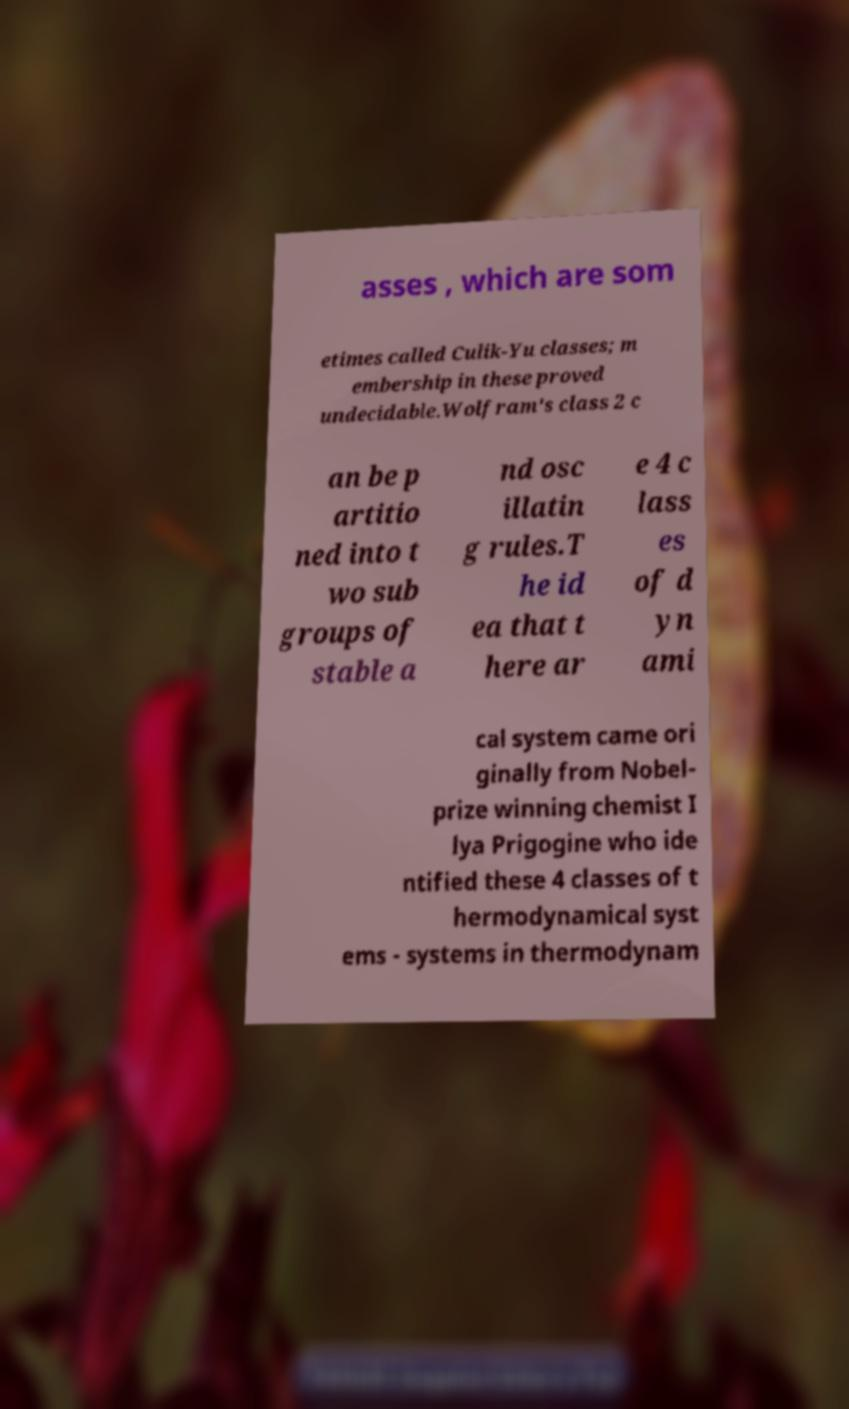Please identify and transcribe the text found in this image. asses , which are som etimes called Culik-Yu classes; m embership in these proved undecidable.Wolfram's class 2 c an be p artitio ned into t wo sub groups of stable a nd osc illatin g rules.T he id ea that t here ar e 4 c lass es of d yn ami cal system came ori ginally from Nobel- prize winning chemist I lya Prigogine who ide ntified these 4 classes of t hermodynamical syst ems - systems in thermodynam 